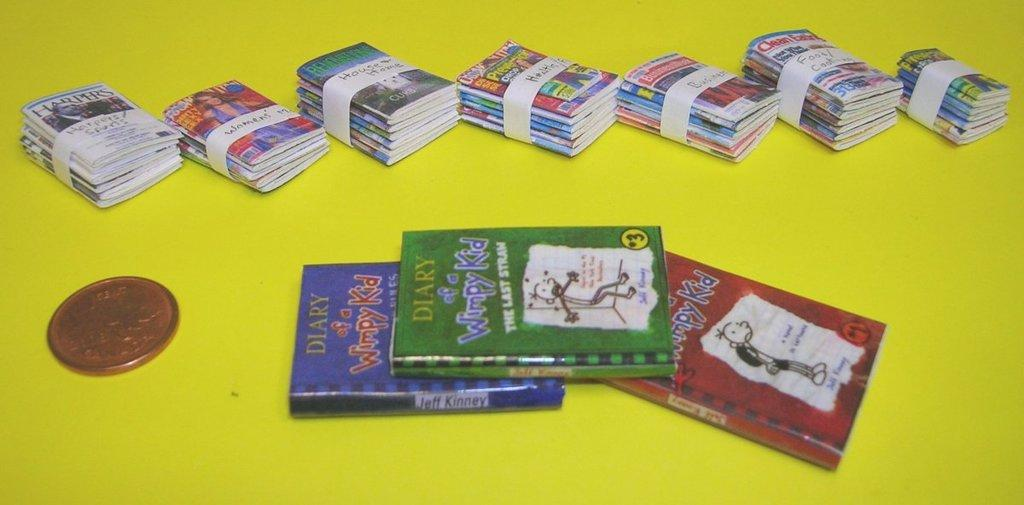What type of objects can be seen in the image? There are many books and a coin in the image. Where are these objects located? The objects are on a desk. What is the color of the desk? The desk is in yellow color. Can you tell me how many tigers are present in the image? There are no tigers present in the image; it only features books, a coin, and a yellow desk. 